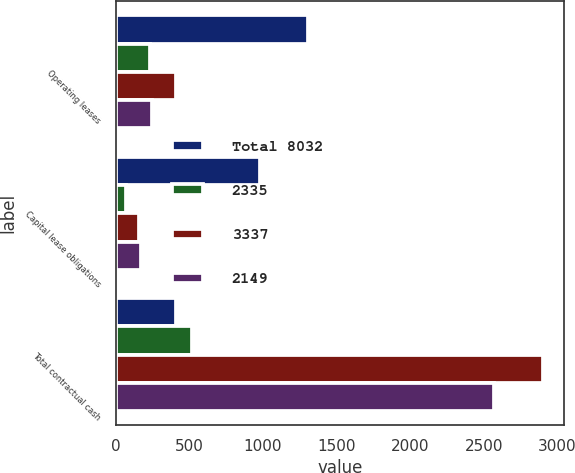Convert chart. <chart><loc_0><loc_0><loc_500><loc_500><stacked_bar_chart><ecel><fcel>Operating leases<fcel>Capital lease obligations<fcel>Total contractual cash<nl><fcel>Total 8032<fcel>1307<fcel>982<fcel>410<nl><fcel>2335<fcel>235<fcel>74<fcel>520<nl><fcel>3337<fcel>410<fcel>157<fcel>2902<nl><fcel>2149<fcel>245<fcel>172<fcel>2566<nl></chart> 